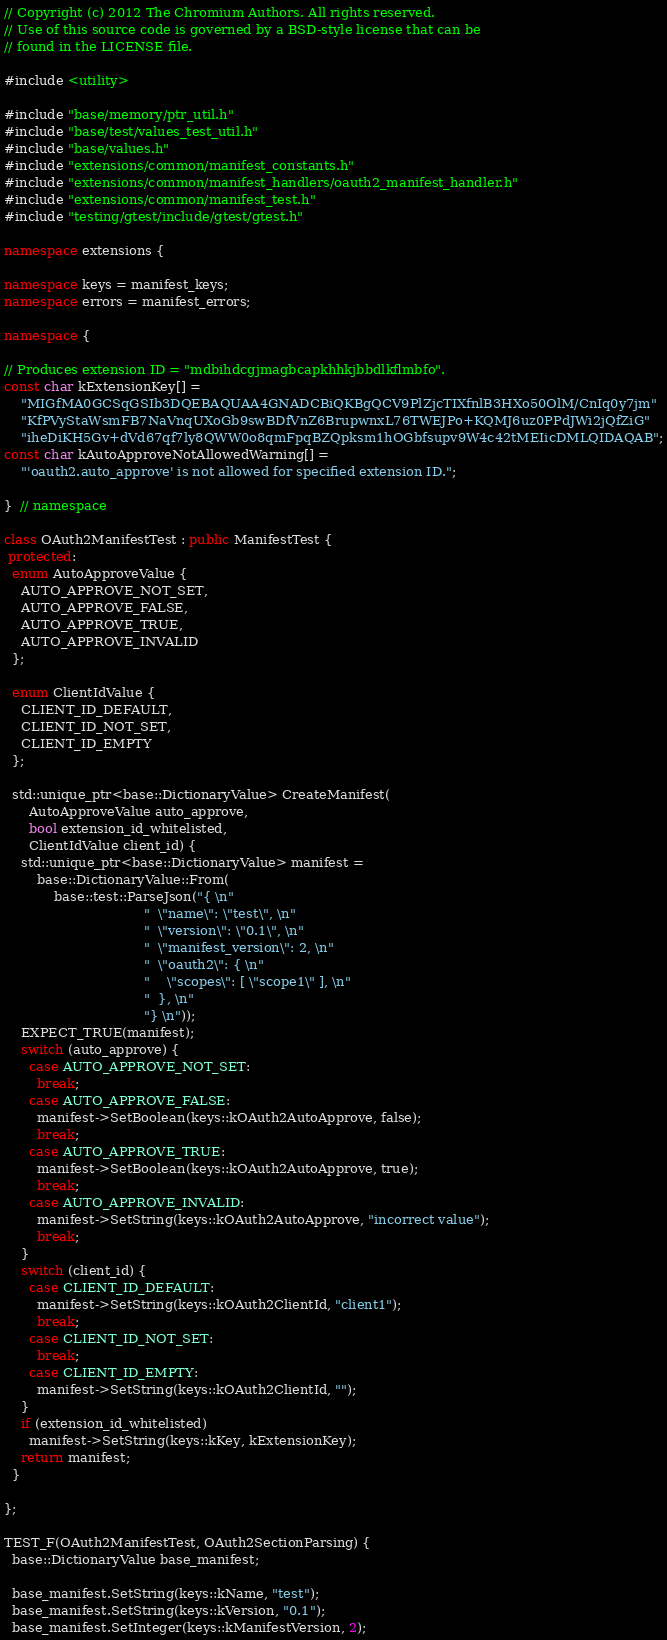<code> <loc_0><loc_0><loc_500><loc_500><_C++_>// Copyright (c) 2012 The Chromium Authors. All rights reserved.
// Use of this source code is governed by a BSD-style license that can be
// found in the LICENSE file.

#include <utility>

#include "base/memory/ptr_util.h"
#include "base/test/values_test_util.h"
#include "base/values.h"
#include "extensions/common/manifest_constants.h"
#include "extensions/common/manifest_handlers/oauth2_manifest_handler.h"
#include "extensions/common/manifest_test.h"
#include "testing/gtest/include/gtest/gtest.h"

namespace extensions {

namespace keys = manifest_keys;
namespace errors = manifest_errors;

namespace {

// Produces extension ID = "mdbihdcgjmagbcapkhhkjbbdlkflmbfo".
const char kExtensionKey[] =
    "MIGfMA0GCSqGSIb3DQEBAQUAA4GNADCBiQKBgQCV9PlZjcTIXfnlB3HXo50OlM/CnIq0y7jm"
    "KfPVyStaWsmFB7NaVnqUXoGb9swBDfVnZ6BrupwnxL76TWEJPo+KQMJ6uz0PPdJWi2jQfZiG"
    "iheDiKH5Gv+dVd67qf7ly8QWW0o8qmFpqBZQpksm1hOGbfsupv9W4c42tMEIicDMLQIDAQAB";
const char kAutoApproveNotAllowedWarning[] =
    "'oauth2.auto_approve' is not allowed for specified extension ID.";

}  // namespace

class OAuth2ManifestTest : public ManifestTest {
 protected:
  enum AutoApproveValue {
    AUTO_APPROVE_NOT_SET,
    AUTO_APPROVE_FALSE,
    AUTO_APPROVE_TRUE,
    AUTO_APPROVE_INVALID
  };

  enum ClientIdValue {
    CLIENT_ID_DEFAULT,
    CLIENT_ID_NOT_SET,
    CLIENT_ID_EMPTY
  };

  std::unique_ptr<base::DictionaryValue> CreateManifest(
      AutoApproveValue auto_approve,
      bool extension_id_whitelisted,
      ClientIdValue client_id) {
    std::unique_ptr<base::DictionaryValue> manifest =
        base::DictionaryValue::From(
            base::test::ParseJson("{ \n"
                                  "  \"name\": \"test\", \n"
                                  "  \"version\": \"0.1\", \n"
                                  "  \"manifest_version\": 2, \n"
                                  "  \"oauth2\": { \n"
                                  "    \"scopes\": [ \"scope1\" ], \n"
                                  "  }, \n"
                                  "} \n"));
    EXPECT_TRUE(manifest);
    switch (auto_approve) {
      case AUTO_APPROVE_NOT_SET:
        break;
      case AUTO_APPROVE_FALSE:
        manifest->SetBoolean(keys::kOAuth2AutoApprove, false);
        break;
      case AUTO_APPROVE_TRUE:
        manifest->SetBoolean(keys::kOAuth2AutoApprove, true);
        break;
      case AUTO_APPROVE_INVALID:
        manifest->SetString(keys::kOAuth2AutoApprove, "incorrect value");
        break;
    }
    switch (client_id) {
      case CLIENT_ID_DEFAULT:
        manifest->SetString(keys::kOAuth2ClientId, "client1");
        break;
      case CLIENT_ID_NOT_SET:
        break;
      case CLIENT_ID_EMPTY:
        manifest->SetString(keys::kOAuth2ClientId, "");
    }
    if (extension_id_whitelisted)
      manifest->SetString(keys::kKey, kExtensionKey);
    return manifest;
  }

};

TEST_F(OAuth2ManifestTest, OAuth2SectionParsing) {
  base::DictionaryValue base_manifest;

  base_manifest.SetString(keys::kName, "test");
  base_manifest.SetString(keys::kVersion, "0.1");
  base_manifest.SetInteger(keys::kManifestVersion, 2);</code> 